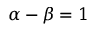Convert formula to latex. <formula><loc_0><loc_0><loc_500><loc_500>\alpha - \beta = 1</formula> 